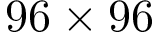<formula> <loc_0><loc_0><loc_500><loc_500>9 6 \times 9 6</formula> 